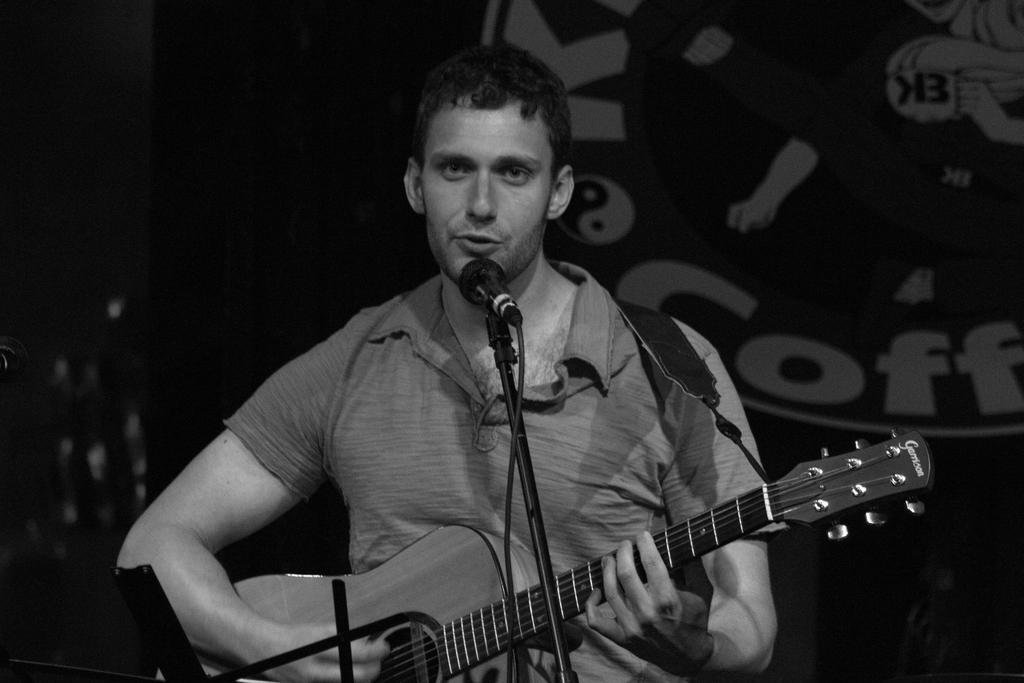What is the person in the image doing? The person is standing and singing. What instrument is the person holding? The person is holding a guitar in his hands. What device is in front of the person for amplifying their voice? There is a microphone in front of the person. Is there any support for the microphone? Yes, there is a stand for the microphone. How many apples can be seen on the guitar in the image? There are no apples present on the guitar in the image. What type of breath control does the person demonstrate while singing? The image does not provide information about the person's breath control while singing. 